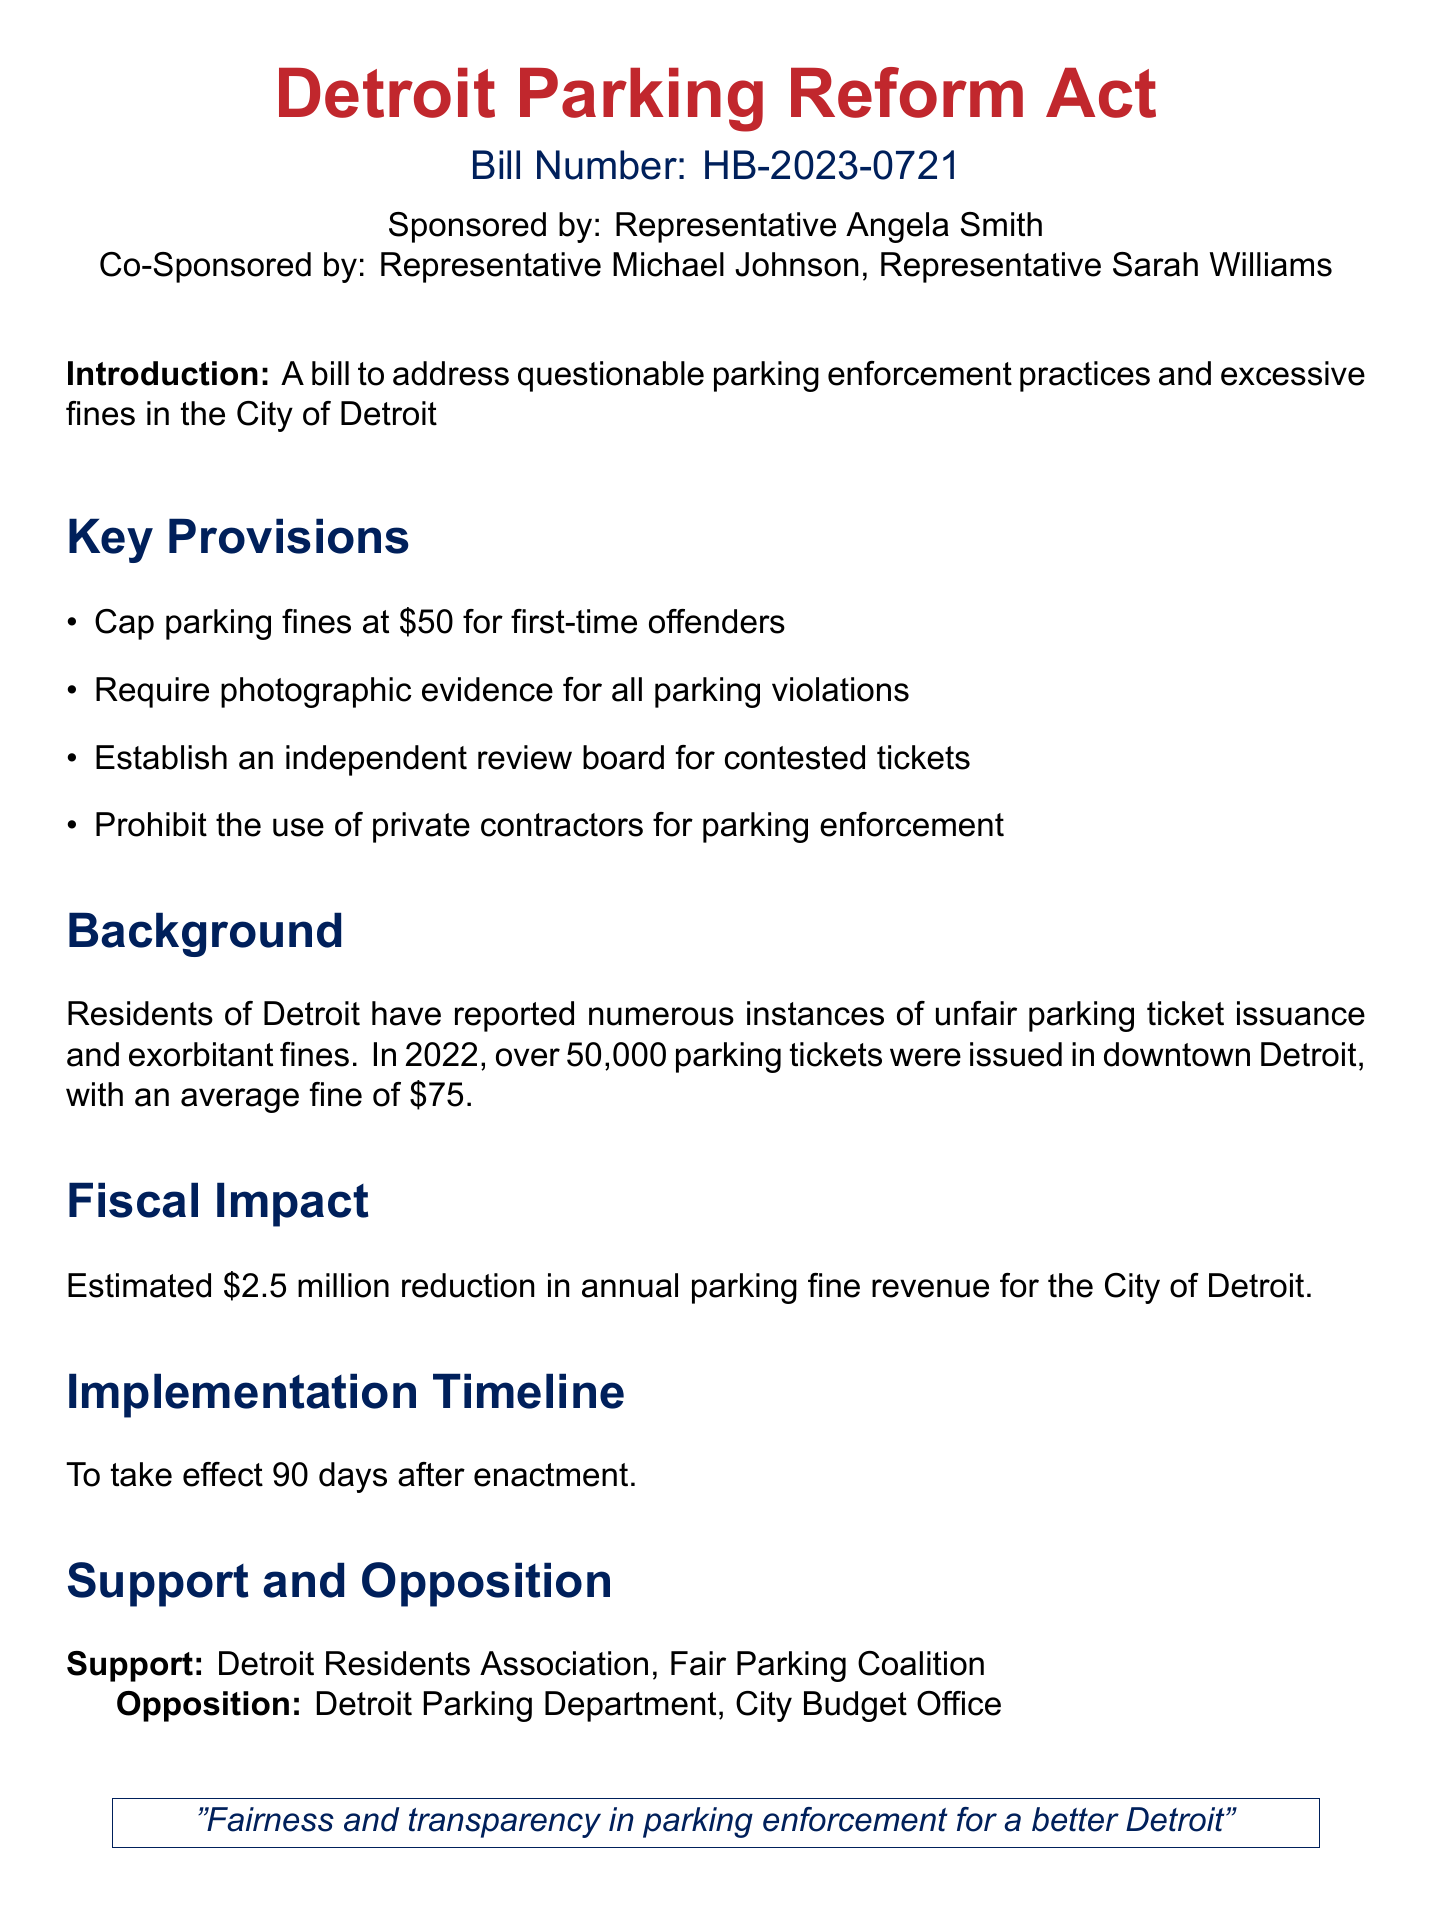What is the cap for parking fines for first-time offenders? The document specifies the cap for parking fines for first-time offenders, which is set at $50.
Answer: $50 How many parking tickets were issued in downtown Detroit in 2022? The document provides the number of tickets issued in 2022, which is over 50,000.
Answer: over 50,000 What is the projected reduction in annual parking fine revenue? The fiscal impact section states the estimated reduction in annual parking fine revenue for the city, which is $2.5 million.
Answer: $2.5 million What is the implementation timeline for the bill? The document states that the bill will take effect 90 days after enactment.
Answer: 90 days Which organizations support the bill? The document lists the supporting organizations as the Detroit Residents Association and the Fair Parking Coalition.
Answer: Detroit Residents Association, Fair Parking Coalition What is the stance of the Detroit Parking Department on the bill? The document mentions the opposition from the Detroit Parking Department towards the bill.
Answer: Opposition What type of tickets does the independent review board handle? The independent review board is established for contested tickets related to parking violations.
Answer: contested tickets 